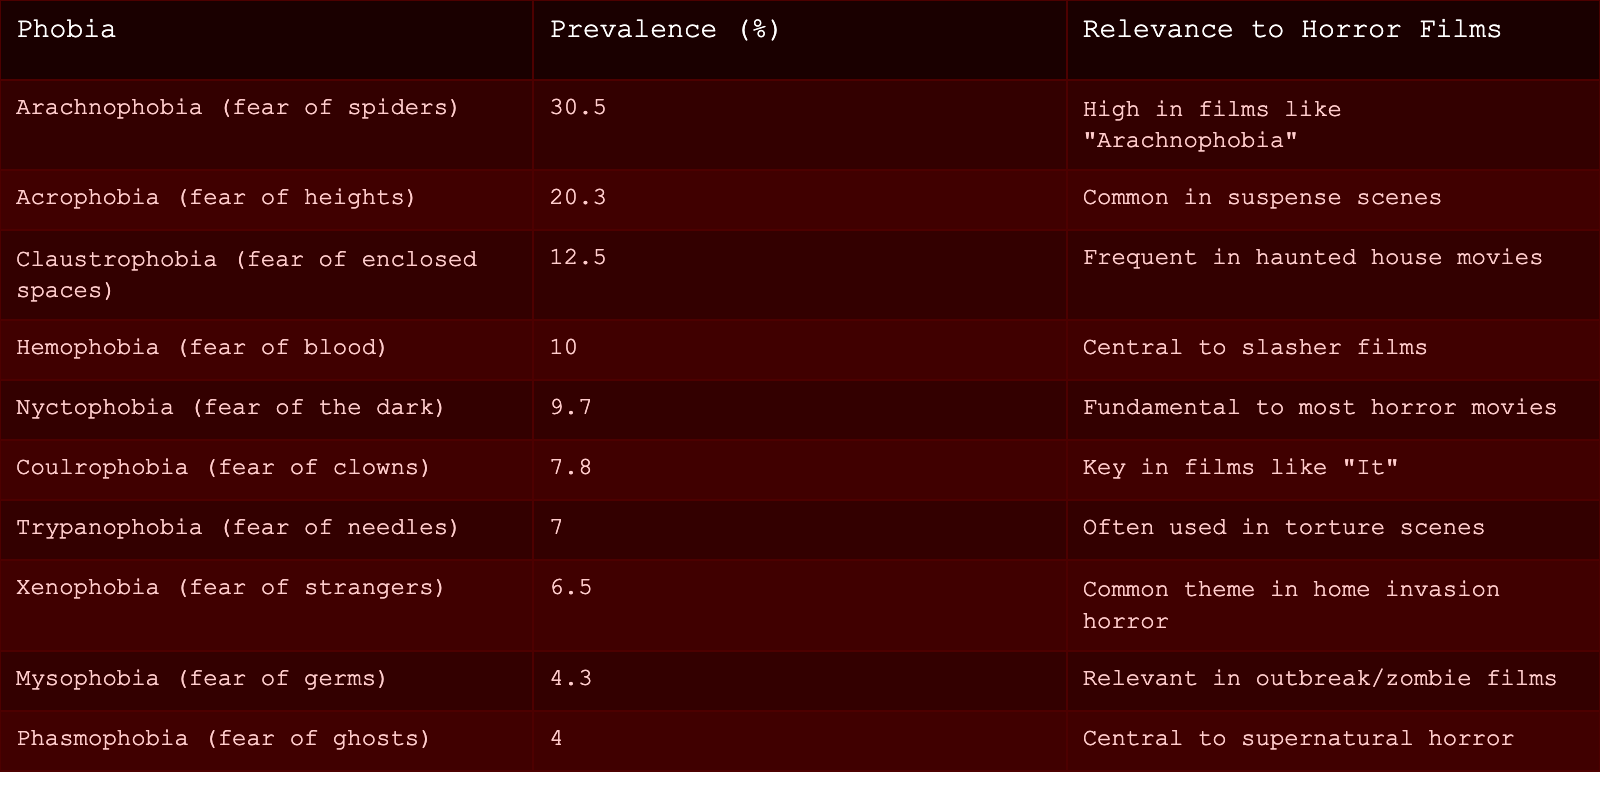What is the most common phobia listed? Looking at the "Prevalence (%)" column, Arachnophobia has the highest percentage at 30.5%. Therefore, it is the most common phobia in the table.
Answer: Arachnophobia How many phobias have a prevalence of over 10%? By examining the "Prevalence (%)" column, we can count the phobias: Arachnophobia (30.5%), Acrophobia (20.3%), Claustrophobia (12.5%), and Hemophobia (10.0%). That's a total of 4 phobias with over 10%.
Answer: 4 Is Nyctophobia relevant to horror films? Yes, the "Relevance to Horror Films" column indicates that Nyctophobia, the fear of the dark, is fundamental to most horror movies, confirming its relevance.
Answer: Yes Which phobia has the lowest prevalence? Phasmophobia (fear of ghosts) appears with a prevalence of 4.0%, which is the lowest percentage in the "Prevalence (%)" column.
Answer: Phasmophobia What is the average prevalence of the phobias mentioned in the table? To find this, we sum all prevalence values: 30.5 + 20.3 + 12.5 + 10.0 + 9.7 + 7.8 + 7.0 + 6.5 + 4.3 + 4.0 =  100.0. Then, divide by the total number of phobias, which is 10, resulting in an average of 100.0 / 10 = 10.0.
Answer: 10.0 How many phobias are specifically linked to horror movies involving clowns? Coulrophobia, with a prevalence of 7.8%, is the only phobia directly linked to horror movies featuring clowns, as indicated in the "Relevance to Horror Films" column.
Answer: 1 Is there a phobia that is mentioned as being related to both slasher and supernatural horror? No, the table indicates that Hemophobia is central to slasher films, while Phasmophobia is central to supernatural horror, meaning none share characteristics related to both.
Answer: No What is the difference in prevalence between Acrophobia and Xenophobia? Acrophobia's prevalence is 20.3%, and Xenophobia's is 6.5%. Therefore, the difference is 20.3 - 6.5 = 13.8%.
Answer: 13.8% 